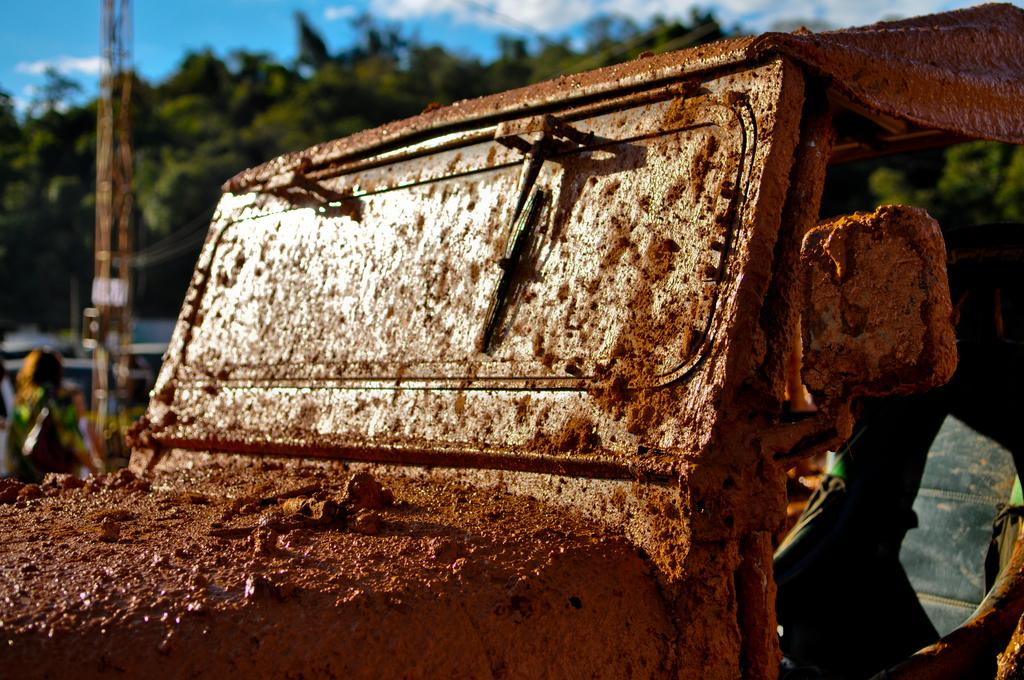What vehicle is present in the image? There is a jeep in the image. Can you describe the person on the right side of the image? There is a person on the right side of the image, but their appearance or actions are not specified. What can be seen in the background of the image? There are trees, a pole, and the sky visible in the background of the image. How many snails are crawling on the jeep in the image? There are no snails visible on the jeep in the image. What type of system is being used by the person in the image? The provided facts do not mention any system or technology being used by the person in the image. --- 